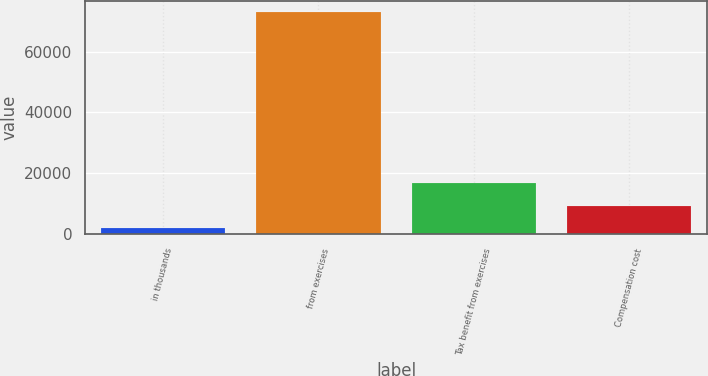<chart> <loc_0><loc_0><loc_500><loc_500><bar_chart><fcel>in thousands<fcel>from exercises<fcel>Tax benefit from exercises<fcel>Compensation cost<nl><fcel>2015<fcel>72884<fcel>16920<fcel>9101.9<nl></chart> 